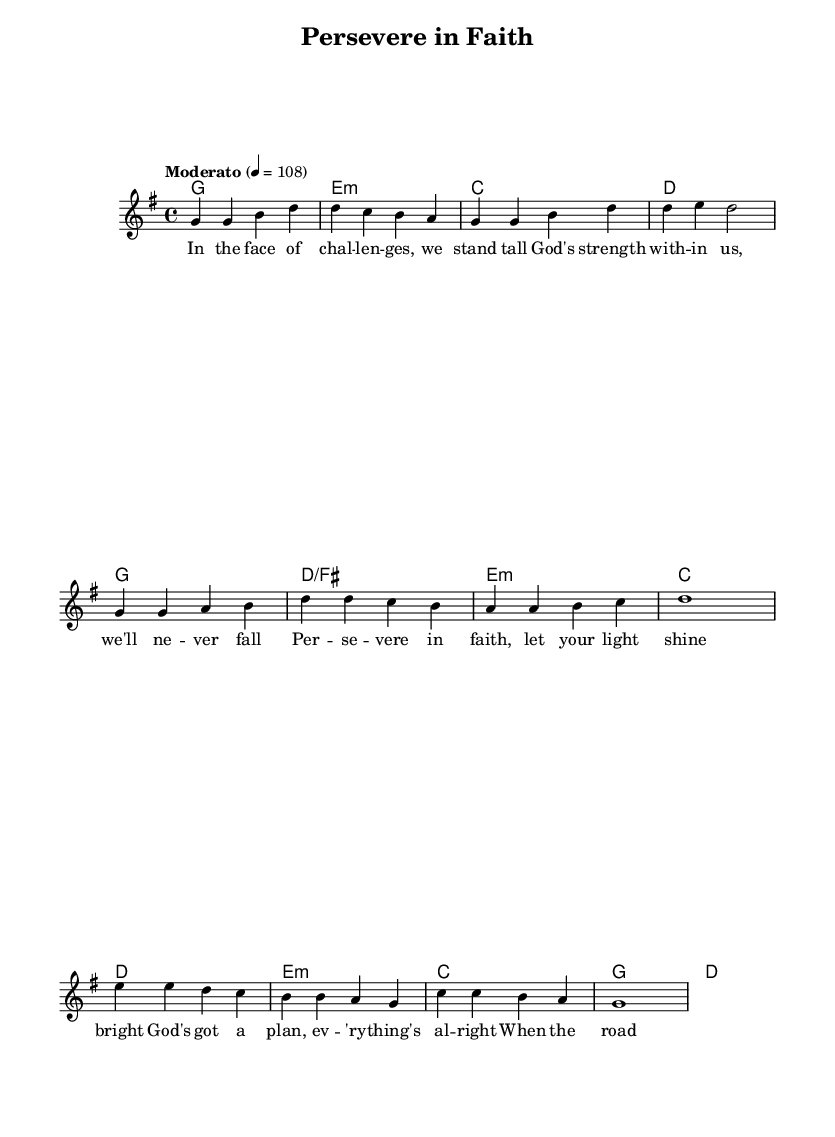What is the key signature of this music? The key signature is G major, which has one sharp (F#). This is indicated at the beginning of the staff.
Answer: G major What is the time signature of this music? The time signature of the piece is 4/4, which means there are four beats in each measure and the quarter note receives one beat. It can be found at the beginning of the score.
Answer: 4/4 What is the tempo marking for this piece? The tempo marking indicates it should be played at "Moderato" with a metronome marking of 108 beats per minute. "Moderato" suggests a moderate tempo, and this is clearly stated in the score.
Answer: Moderato How many measures are in the verse section? The verse section consists of four measures, which can be counted directly by examining the melody line marked for the verse.
Answer: 4 What is the main lyrical theme of the chorus? The main lyrical theme of the chorus is perseverance in faith, as expressed in the lines about letting one's light shine bright and trusting in God's plan. This theme is evident in the lyrics of the chorus section.
Answer: Persevere What chords are used in the bridge section? The chords in the bridge section are E minor, C, G, and D. This is determined by looking at the chord symbols placed above the melody in the bridge part of the score.
Answer: E minor, C, G, D How does the melody reflect the song's theme of strength? The melody features rising notes and a steady rhythm which contributes to an uplifting and strong feeling, supporting the lyrics about God's love making us strong. This can be analyzed by listening to the melody's contour and its phrasing in relation to the lyrics.
Answer: Uplifting and strong 